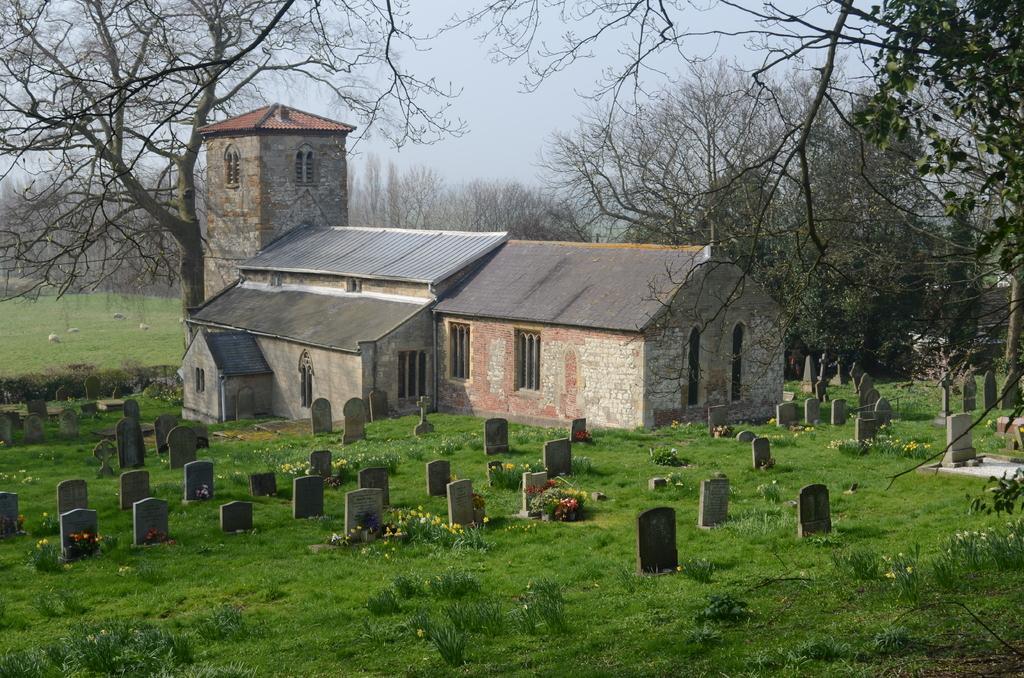How would you summarize this image in a sentence or two? In this picture we can see a house here, at the bottom there is grass, we can see some graves here, in the background there are some trees, we can see the sky at the top of the picture. 